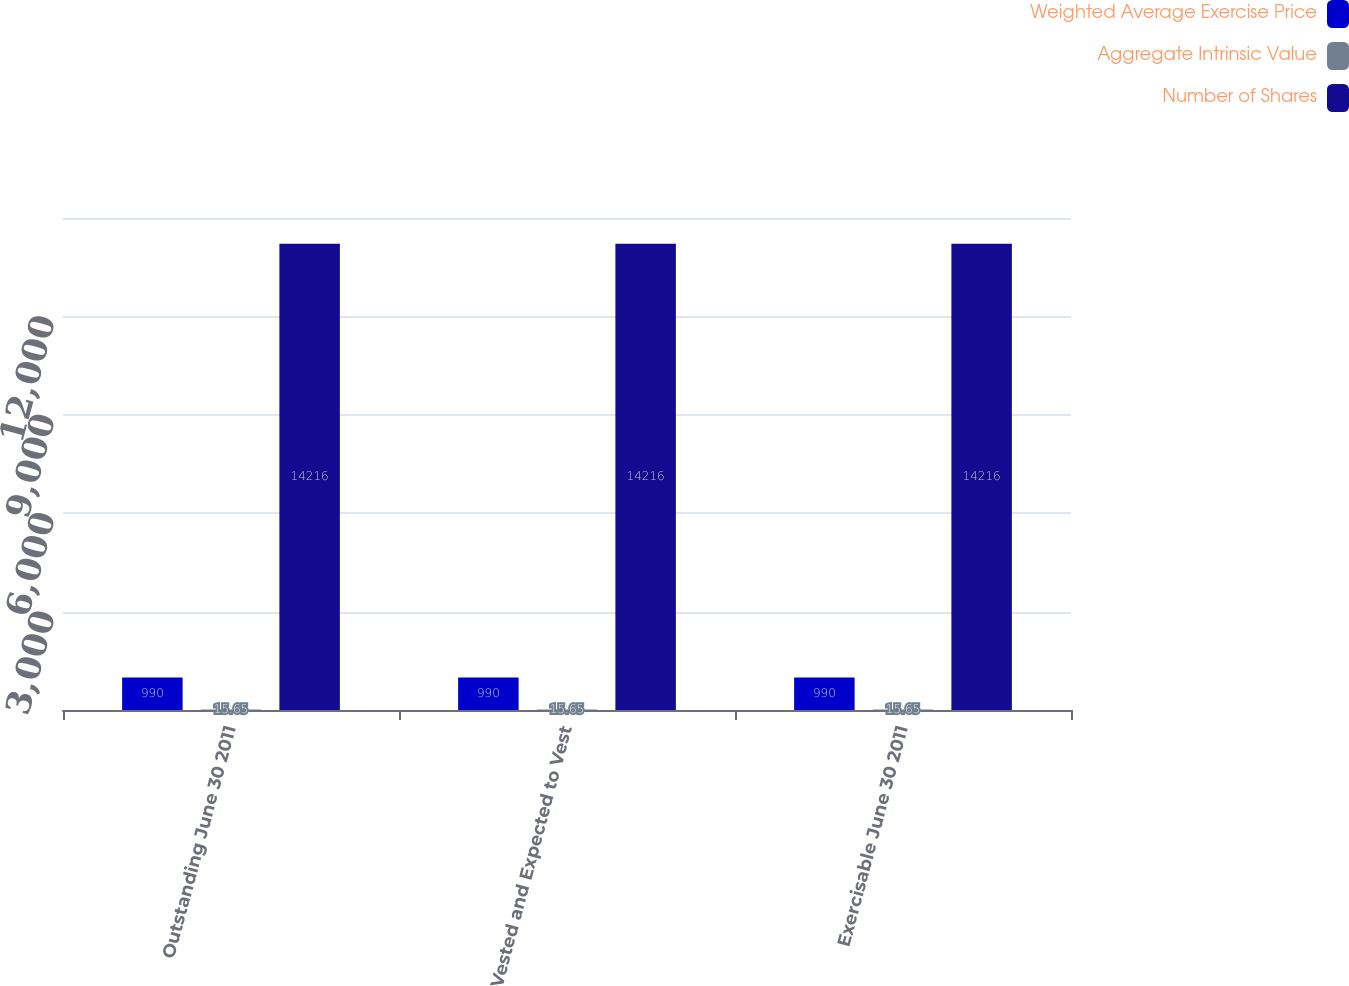Convert chart to OTSL. <chart><loc_0><loc_0><loc_500><loc_500><stacked_bar_chart><ecel><fcel>Outstanding June 30 2011<fcel>Vested and Expected to Vest<fcel>Exercisable June 30 2011<nl><fcel>Weighted Average Exercise Price<fcel>990<fcel>990<fcel>990<nl><fcel>Aggregate Intrinsic Value<fcel>15.65<fcel>15.65<fcel>15.65<nl><fcel>Number of Shares<fcel>14216<fcel>14216<fcel>14216<nl></chart> 